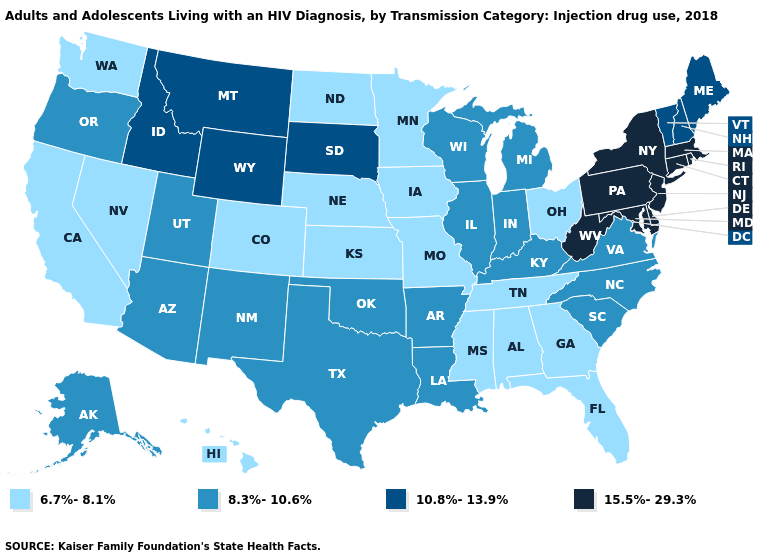What is the value of Arizona?
Quick response, please. 8.3%-10.6%. Which states hav the highest value in the MidWest?
Be succinct. South Dakota. Which states have the highest value in the USA?
Short answer required. Connecticut, Delaware, Maryland, Massachusetts, New Jersey, New York, Pennsylvania, Rhode Island, West Virginia. Does Louisiana have a higher value than Tennessee?
Keep it brief. Yes. Does Washington have the lowest value in the West?
Write a very short answer. Yes. What is the value of Hawaii?
Quick response, please. 6.7%-8.1%. Does New Hampshire have the highest value in the Northeast?
Quick response, please. No. Does Maine have the highest value in the Northeast?
Be succinct. No. Which states hav the highest value in the South?
Quick response, please. Delaware, Maryland, West Virginia. Which states have the lowest value in the Northeast?
Be succinct. Maine, New Hampshire, Vermont. What is the lowest value in states that border Ohio?
Write a very short answer. 8.3%-10.6%. Among the states that border Oregon , which have the lowest value?
Short answer required. California, Nevada, Washington. How many symbols are there in the legend?
Be succinct. 4. Which states hav the highest value in the West?
Give a very brief answer. Idaho, Montana, Wyoming. 